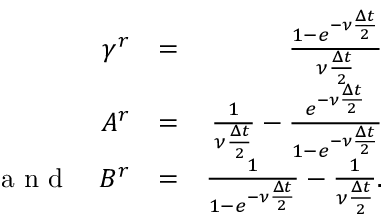Convert formula to latex. <formula><loc_0><loc_0><loc_500><loc_500>\begin{array} { r l r } { \gamma ^ { r } } & { = } & { \frac { 1 - e ^ { - \nu \frac { \Delta t } { 2 } } } { \nu \frac { \Delta t } { 2 } } } \\ { A ^ { r } } & { = } & { \frac { 1 } { \nu \frac { \Delta t } { 2 } } - \frac { e ^ { - \nu \frac { \Delta t } { 2 } } } { 1 - e ^ { - \nu \frac { \Delta t } { 2 } } } } \\ { a n d \quad B ^ { r } } & { = } & { \frac { 1 } { 1 - e ^ { - \nu \frac { \Delta t } { 2 } } } - \frac { 1 } { \nu \frac { \Delta t } { 2 } } . } \end{array}</formula> 